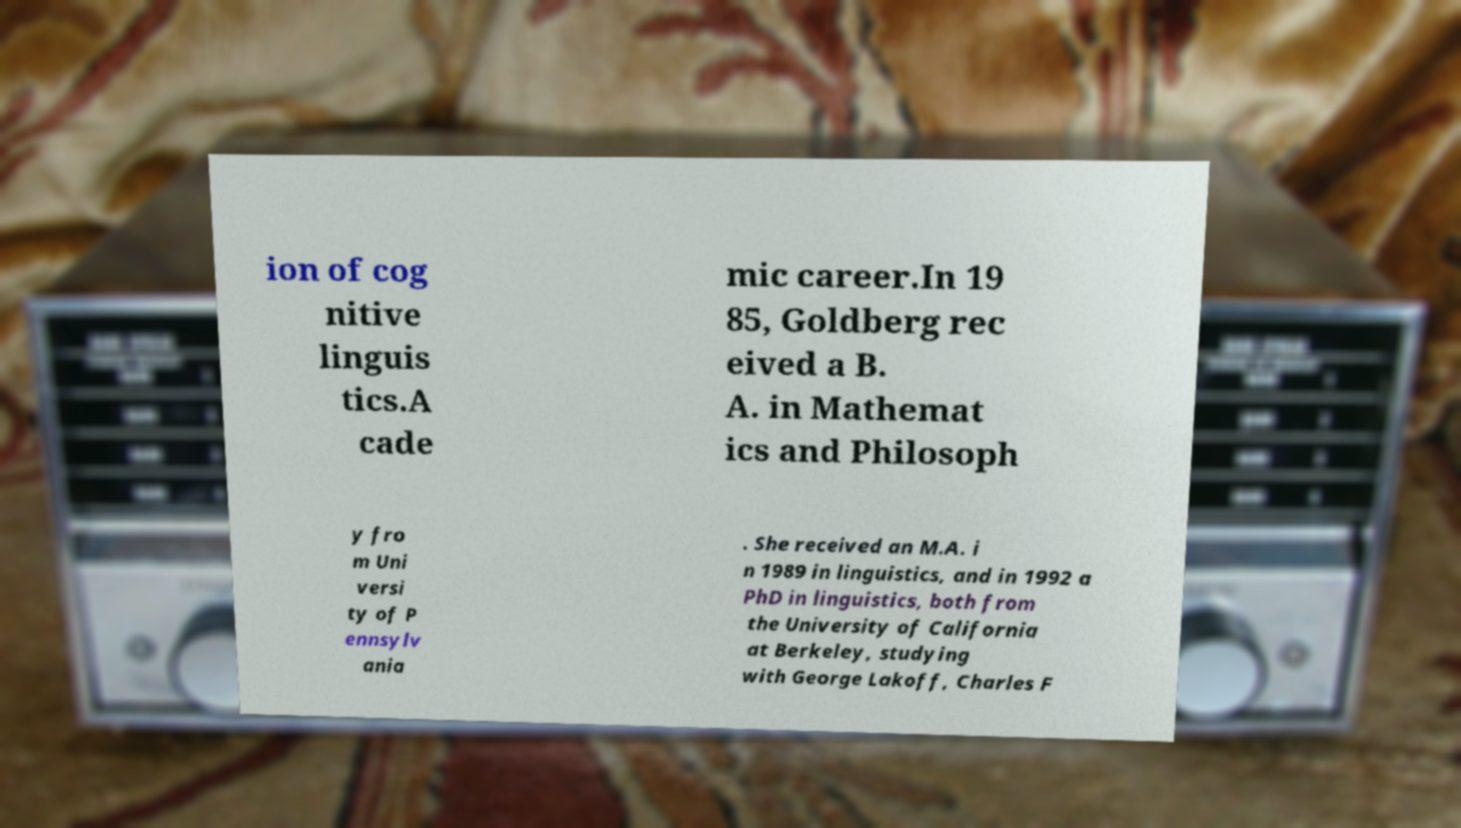What messages or text are displayed in this image? I need them in a readable, typed format. ion of cog nitive linguis tics.A cade mic career.In 19 85, Goldberg rec eived a B. A. in Mathemat ics and Philosoph y fro m Uni versi ty of P ennsylv ania . She received an M.A. i n 1989 in linguistics, and in 1992 a PhD in linguistics, both from the University of California at Berkeley, studying with George Lakoff, Charles F 